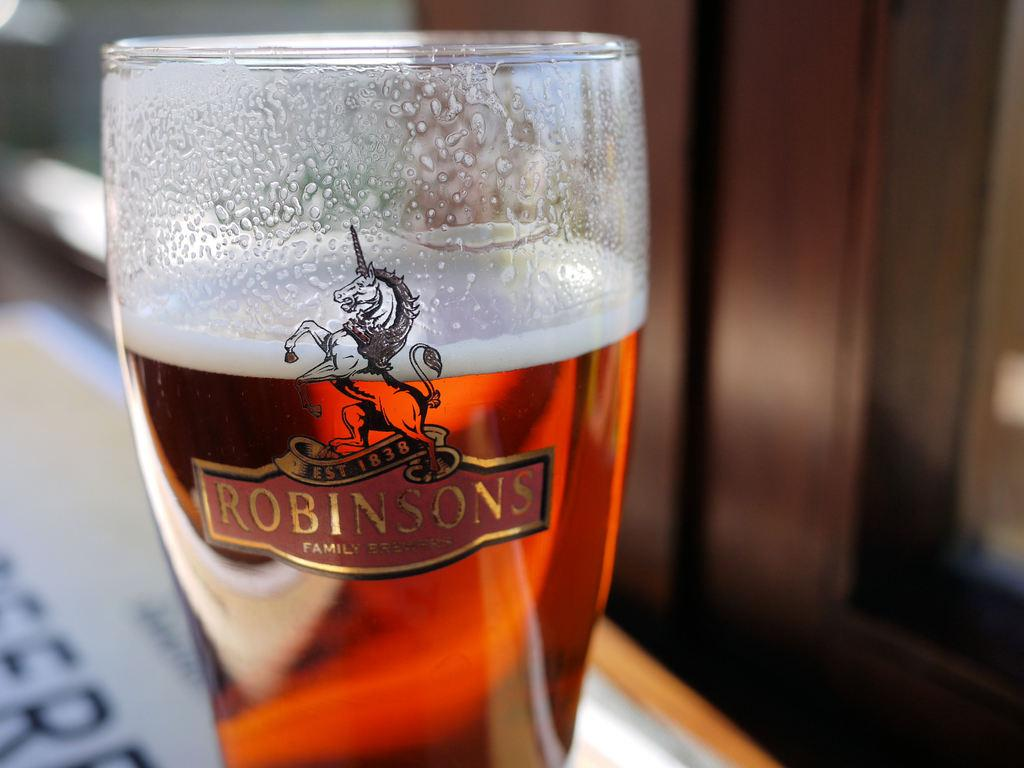<image>
Present a compact description of the photo's key features. Tall glass of beer with the name Robinsons on it and a unicorn. 